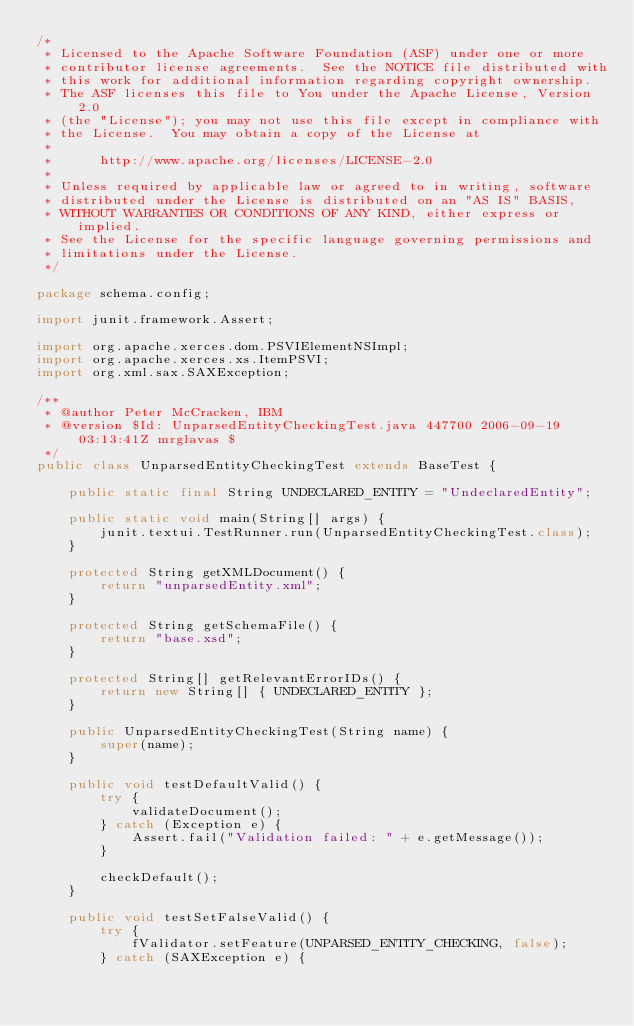Convert code to text. <code><loc_0><loc_0><loc_500><loc_500><_Java_>/*
 * Licensed to the Apache Software Foundation (ASF) under one or more
 * contributor license agreements.  See the NOTICE file distributed with
 * this work for additional information regarding copyright ownership.
 * The ASF licenses this file to You under the Apache License, Version 2.0
 * (the "License"); you may not use this file except in compliance with
 * the License.  You may obtain a copy of the License at
 * 
 *      http://www.apache.org/licenses/LICENSE-2.0
 * 
 * Unless required by applicable law or agreed to in writing, software
 * distributed under the License is distributed on an "AS IS" BASIS,
 * WITHOUT WARRANTIES OR CONDITIONS OF ANY KIND, either express or implied.
 * See the License for the specific language governing permissions and
 * limitations under the License.
 */

package schema.config;

import junit.framework.Assert;

import org.apache.xerces.dom.PSVIElementNSImpl;
import org.apache.xerces.xs.ItemPSVI;
import org.xml.sax.SAXException;

/**
 * @author Peter McCracken, IBM
 * @version $Id: UnparsedEntityCheckingTest.java 447700 2006-09-19 03:13:41Z mrglavas $
 */
public class UnparsedEntityCheckingTest extends BaseTest {
    
    public static final String UNDECLARED_ENTITY = "UndeclaredEntity";
    
    public static void main(String[] args) {
        junit.textui.TestRunner.run(UnparsedEntityCheckingTest.class);
    }
    
    protected String getXMLDocument() {
        return "unparsedEntity.xml";
    }
    
    protected String getSchemaFile() {
        return "base.xsd";
    }
    
    protected String[] getRelevantErrorIDs() {
        return new String[] { UNDECLARED_ENTITY };
    }
    
    public UnparsedEntityCheckingTest(String name) {
        super(name);
    }
    
    public void testDefaultValid() {
        try {
            validateDocument();
        } catch (Exception e) {
            Assert.fail("Validation failed: " + e.getMessage());
        }
        
        checkDefault();
    }
    
    public void testSetFalseValid() {
        try {
            fValidator.setFeature(UNPARSED_ENTITY_CHECKING, false);
        } catch (SAXException e) {</code> 